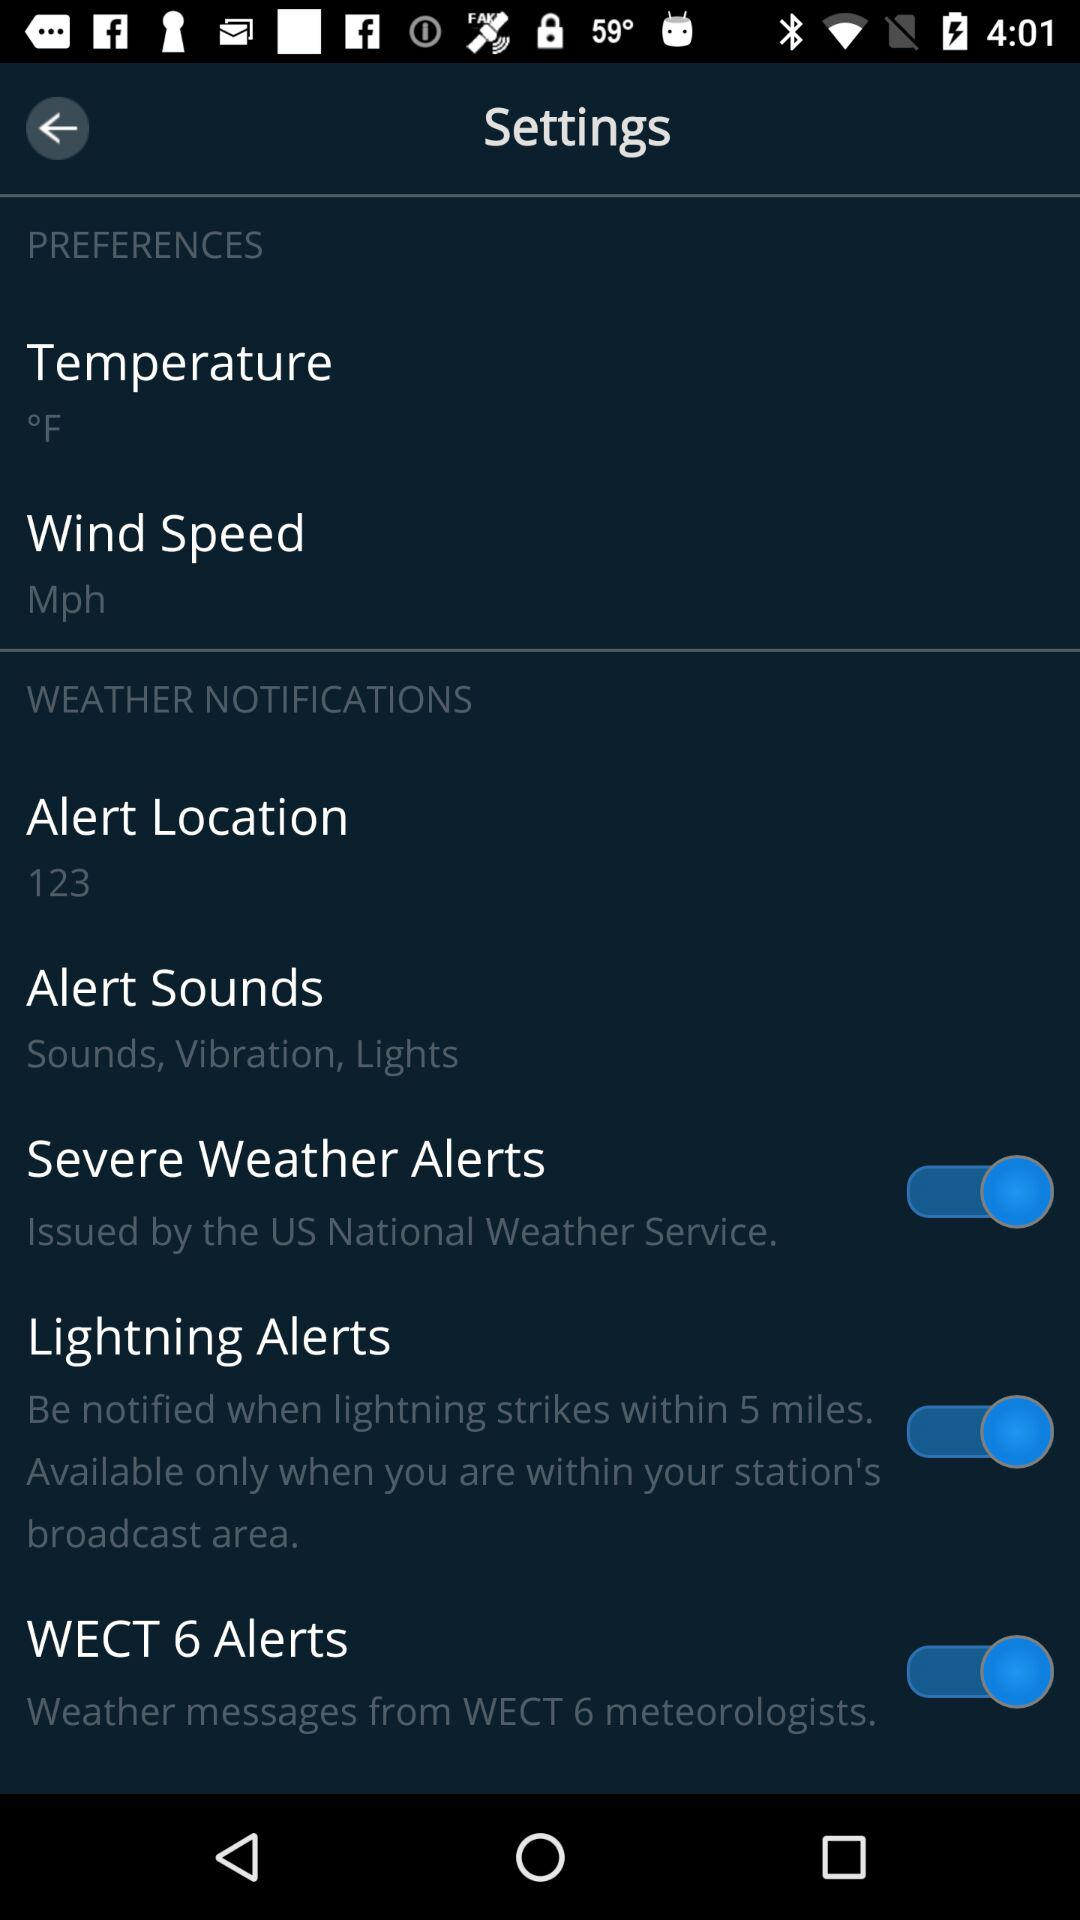What is the status of "Lightning Alerts"? The status is "on". 